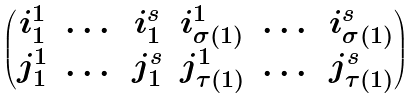Convert formula to latex. <formula><loc_0><loc_0><loc_500><loc_500>\begin{pmatrix} i _ { 1 } ^ { 1 } & \dots & i _ { 1 } ^ { s } & i _ { \sigma ( 1 ) } ^ { 1 } & \dots & i _ { \sigma ( 1 ) } ^ { s } \\ j _ { 1 } ^ { 1 } & \dots & j _ { 1 } ^ { s } & j _ { \tau ( 1 ) } ^ { 1 } & \dots & j _ { \tau ( 1 ) } ^ { s } \end{pmatrix}</formula> 